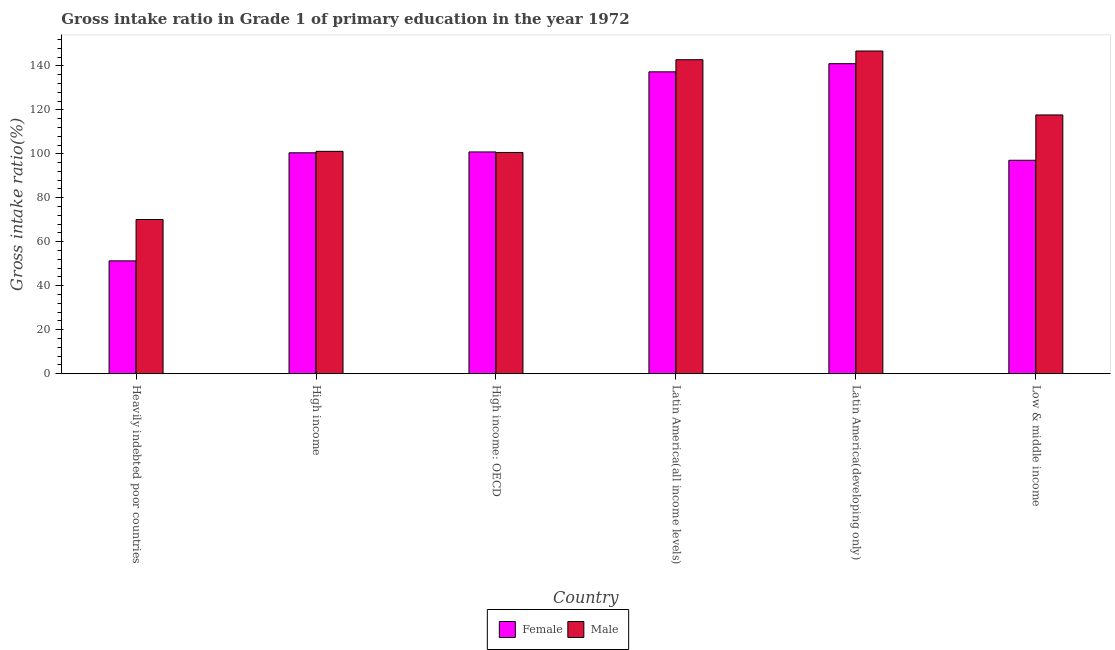How many different coloured bars are there?
Your answer should be very brief. 2. How many groups of bars are there?
Your response must be concise. 6. Are the number of bars per tick equal to the number of legend labels?
Offer a very short reply. Yes. How many bars are there on the 5th tick from the left?
Your response must be concise. 2. What is the label of the 3rd group of bars from the left?
Your answer should be very brief. High income: OECD. What is the gross intake ratio(male) in Heavily indebted poor countries?
Make the answer very short. 70.13. Across all countries, what is the maximum gross intake ratio(female)?
Provide a succinct answer. 140.97. Across all countries, what is the minimum gross intake ratio(female)?
Provide a short and direct response. 51.32. In which country was the gross intake ratio(male) maximum?
Offer a very short reply. Latin America(developing only). In which country was the gross intake ratio(female) minimum?
Offer a very short reply. Heavily indebted poor countries. What is the total gross intake ratio(male) in the graph?
Make the answer very short. 679.07. What is the difference between the gross intake ratio(male) in Latin America(all income levels) and that in Latin America(developing only)?
Offer a terse response. -3.96. What is the difference between the gross intake ratio(female) in Low & middle income and the gross intake ratio(male) in High income?
Provide a short and direct response. -4.07. What is the average gross intake ratio(male) per country?
Ensure brevity in your answer.  113.18. What is the difference between the gross intake ratio(male) and gross intake ratio(female) in Latin America(all income levels)?
Offer a terse response. 5.51. In how many countries, is the gross intake ratio(female) greater than 36 %?
Your answer should be compact. 6. What is the ratio of the gross intake ratio(male) in High income: OECD to that in Latin America(all income levels)?
Your response must be concise. 0.7. What is the difference between the highest and the second highest gross intake ratio(female)?
Provide a short and direct response. 3.7. What is the difference between the highest and the lowest gross intake ratio(male)?
Offer a very short reply. 76.61. In how many countries, is the gross intake ratio(female) greater than the average gross intake ratio(female) taken over all countries?
Keep it short and to the point. 2. What does the 2nd bar from the left in Latin America(all income levels) represents?
Give a very brief answer. Male. Are all the bars in the graph horizontal?
Your answer should be compact. No. What is the difference between two consecutive major ticks on the Y-axis?
Provide a succinct answer. 20. Are the values on the major ticks of Y-axis written in scientific E-notation?
Ensure brevity in your answer.  No. Does the graph contain any zero values?
Make the answer very short. No. Where does the legend appear in the graph?
Make the answer very short. Bottom center. How are the legend labels stacked?
Keep it short and to the point. Horizontal. What is the title of the graph?
Your answer should be very brief. Gross intake ratio in Grade 1 of primary education in the year 1972. What is the label or title of the Y-axis?
Offer a very short reply. Gross intake ratio(%). What is the Gross intake ratio(%) in Female in Heavily indebted poor countries?
Give a very brief answer. 51.32. What is the Gross intake ratio(%) in Male in Heavily indebted poor countries?
Provide a short and direct response. 70.13. What is the Gross intake ratio(%) of Female in High income?
Provide a short and direct response. 100.46. What is the Gross intake ratio(%) in Male in High income?
Your answer should be compact. 101.13. What is the Gross intake ratio(%) in Female in High income: OECD?
Offer a terse response. 100.85. What is the Gross intake ratio(%) of Male in High income: OECD?
Keep it short and to the point. 100.62. What is the Gross intake ratio(%) of Female in Latin America(all income levels)?
Ensure brevity in your answer.  137.27. What is the Gross intake ratio(%) of Male in Latin America(all income levels)?
Your response must be concise. 142.78. What is the Gross intake ratio(%) of Female in Latin America(developing only)?
Provide a succinct answer. 140.97. What is the Gross intake ratio(%) of Male in Latin America(developing only)?
Keep it short and to the point. 146.74. What is the Gross intake ratio(%) in Female in Low & middle income?
Make the answer very short. 97.06. What is the Gross intake ratio(%) of Male in Low & middle income?
Your answer should be very brief. 117.67. Across all countries, what is the maximum Gross intake ratio(%) in Female?
Provide a short and direct response. 140.97. Across all countries, what is the maximum Gross intake ratio(%) of Male?
Give a very brief answer. 146.74. Across all countries, what is the minimum Gross intake ratio(%) of Female?
Keep it short and to the point. 51.32. Across all countries, what is the minimum Gross intake ratio(%) of Male?
Provide a short and direct response. 70.13. What is the total Gross intake ratio(%) in Female in the graph?
Offer a terse response. 627.94. What is the total Gross intake ratio(%) of Male in the graph?
Provide a short and direct response. 679.07. What is the difference between the Gross intake ratio(%) of Female in Heavily indebted poor countries and that in High income?
Provide a short and direct response. -49.14. What is the difference between the Gross intake ratio(%) of Male in Heavily indebted poor countries and that in High income?
Ensure brevity in your answer.  -31. What is the difference between the Gross intake ratio(%) in Female in Heavily indebted poor countries and that in High income: OECD?
Make the answer very short. -49.52. What is the difference between the Gross intake ratio(%) in Male in Heavily indebted poor countries and that in High income: OECD?
Give a very brief answer. -30.49. What is the difference between the Gross intake ratio(%) of Female in Heavily indebted poor countries and that in Latin America(all income levels)?
Provide a succinct answer. -85.95. What is the difference between the Gross intake ratio(%) in Male in Heavily indebted poor countries and that in Latin America(all income levels)?
Provide a succinct answer. -72.65. What is the difference between the Gross intake ratio(%) in Female in Heavily indebted poor countries and that in Latin America(developing only)?
Make the answer very short. -89.65. What is the difference between the Gross intake ratio(%) of Male in Heavily indebted poor countries and that in Latin America(developing only)?
Keep it short and to the point. -76.61. What is the difference between the Gross intake ratio(%) in Female in Heavily indebted poor countries and that in Low & middle income?
Your answer should be compact. -45.74. What is the difference between the Gross intake ratio(%) in Male in Heavily indebted poor countries and that in Low & middle income?
Make the answer very short. -47.54. What is the difference between the Gross intake ratio(%) in Female in High income and that in High income: OECD?
Your answer should be compact. -0.39. What is the difference between the Gross intake ratio(%) in Male in High income and that in High income: OECD?
Keep it short and to the point. 0.51. What is the difference between the Gross intake ratio(%) in Female in High income and that in Latin America(all income levels)?
Give a very brief answer. -36.81. What is the difference between the Gross intake ratio(%) in Male in High income and that in Latin America(all income levels)?
Your answer should be very brief. -41.66. What is the difference between the Gross intake ratio(%) of Female in High income and that in Latin America(developing only)?
Make the answer very short. -40.51. What is the difference between the Gross intake ratio(%) of Male in High income and that in Latin America(developing only)?
Your response must be concise. -45.61. What is the difference between the Gross intake ratio(%) of Female in High income and that in Low & middle income?
Offer a terse response. 3.4. What is the difference between the Gross intake ratio(%) of Male in High income and that in Low & middle income?
Your response must be concise. -16.54. What is the difference between the Gross intake ratio(%) in Female in High income: OECD and that in Latin America(all income levels)?
Keep it short and to the point. -36.42. What is the difference between the Gross intake ratio(%) in Male in High income: OECD and that in Latin America(all income levels)?
Provide a succinct answer. -42.17. What is the difference between the Gross intake ratio(%) of Female in High income: OECD and that in Latin America(developing only)?
Offer a terse response. -40.13. What is the difference between the Gross intake ratio(%) in Male in High income: OECD and that in Latin America(developing only)?
Your response must be concise. -46.13. What is the difference between the Gross intake ratio(%) in Female in High income: OECD and that in Low & middle income?
Give a very brief answer. 3.79. What is the difference between the Gross intake ratio(%) of Male in High income: OECD and that in Low & middle income?
Your answer should be very brief. -17.05. What is the difference between the Gross intake ratio(%) in Female in Latin America(all income levels) and that in Latin America(developing only)?
Give a very brief answer. -3.7. What is the difference between the Gross intake ratio(%) of Male in Latin America(all income levels) and that in Latin America(developing only)?
Make the answer very short. -3.96. What is the difference between the Gross intake ratio(%) of Female in Latin America(all income levels) and that in Low & middle income?
Provide a short and direct response. 40.21. What is the difference between the Gross intake ratio(%) in Male in Latin America(all income levels) and that in Low & middle income?
Offer a very short reply. 25.11. What is the difference between the Gross intake ratio(%) of Female in Latin America(developing only) and that in Low & middle income?
Give a very brief answer. 43.91. What is the difference between the Gross intake ratio(%) of Male in Latin America(developing only) and that in Low & middle income?
Make the answer very short. 29.07. What is the difference between the Gross intake ratio(%) in Female in Heavily indebted poor countries and the Gross intake ratio(%) in Male in High income?
Keep it short and to the point. -49.81. What is the difference between the Gross intake ratio(%) of Female in Heavily indebted poor countries and the Gross intake ratio(%) of Male in High income: OECD?
Provide a succinct answer. -49.29. What is the difference between the Gross intake ratio(%) of Female in Heavily indebted poor countries and the Gross intake ratio(%) of Male in Latin America(all income levels)?
Provide a short and direct response. -91.46. What is the difference between the Gross intake ratio(%) in Female in Heavily indebted poor countries and the Gross intake ratio(%) in Male in Latin America(developing only)?
Offer a very short reply. -95.42. What is the difference between the Gross intake ratio(%) in Female in Heavily indebted poor countries and the Gross intake ratio(%) in Male in Low & middle income?
Give a very brief answer. -66.35. What is the difference between the Gross intake ratio(%) in Female in High income and the Gross intake ratio(%) in Male in High income: OECD?
Ensure brevity in your answer.  -0.16. What is the difference between the Gross intake ratio(%) of Female in High income and the Gross intake ratio(%) of Male in Latin America(all income levels)?
Offer a terse response. -42.32. What is the difference between the Gross intake ratio(%) of Female in High income and the Gross intake ratio(%) of Male in Latin America(developing only)?
Ensure brevity in your answer.  -46.28. What is the difference between the Gross intake ratio(%) of Female in High income and the Gross intake ratio(%) of Male in Low & middle income?
Your answer should be compact. -17.21. What is the difference between the Gross intake ratio(%) in Female in High income: OECD and the Gross intake ratio(%) in Male in Latin America(all income levels)?
Ensure brevity in your answer.  -41.94. What is the difference between the Gross intake ratio(%) in Female in High income: OECD and the Gross intake ratio(%) in Male in Latin America(developing only)?
Your response must be concise. -45.89. What is the difference between the Gross intake ratio(%) in Female in High income: OECD and the Gross intake ratio(%) in Male in Low & middle income?
Ensure brevity in your answer.  -16.82. What is the difference between the Gross intake ratio(%) of Female in Latin America(all income levels) and the Gross intake ratio(%) of Male in Latin America(developing only)?
Your response must be concise. -9.47. What is the difference between the Gross intake ratio(%) of Female in Latin America(all income levels) and the Gross intake ratio(%) of Male in Low & middle income?
Make the answer very short. 19.6. What is the difference between the Gross intake ratio(%) in Female in Latin America(developing only) and the Gross intake ratio(%) in Male in Low & middle income?
Provide a short and direct response. 23.3. What is the average Gross intake ratio(%) of Female per country?
Provide a short and direct response. 104.66. What is the average Gross intake ratio(%) in Male per country?
Provide a succinct answer. 113.18. What is the difference between the Gross intake ratio(%) in Female and Gross intake ratio(%) in Male in Heavily indebted poor countries?
Offer a very short reply. -18.81. What is the difference between the Gross intake ratio(%) of Female and Gross intake ratio(%) of Male in High income?
Provide a short and direct response. -0.67. What is the difference between the Gross intake ratio(%) in Female and Gross intake ratio(%) in Male in High income: OECD?
Keep it short and to the point. 0.23. What is the difference between the Gross intake ratio(%) in Female and Gross intake ratio(%) in Male in Latin America(all income levels)?
Your response must be concise. -5.51. What is the difference between the Gross intake ratio(%) of Female and Gross intake ratio(%) of Male in Latin America(developing only)?
Your response must be concise. -5.77. What is the difference between the Gross intake ratio(%) in Female and Gross intake ratio(%) in Male in Low & middle income?
Provide a short and direct response. -20.61. What is the ratio of the Gross intake ratio(%) in Female in Heavily indebted poor countries to that in High income?
Give a very brief answer. 0.51. What is the ratio of the Gross intake ratio(%) in Male in Heavily indebted poor countries to that in High income?
Offer a terse response. 0.69. What is the ratio of the Gross intake ratio(%) in Female in Heavily indebted poor countries to that in High income: OECD?
Your response must be concise. 0.51. What is the ratio of the Gross intake ratio(%) in Male in Heavily indebted poor countries to that in High income: OECD?
Make the answer very short. 0.7. What is the ratio of the Gross intake ratio(%) in Female in Heavily indebted poor countries to that in Latin America(all income levels)?
Give a very brief answer. 0.37. What is the ratio of the Gross intake ratio(%) of Male in Heavily indebted poor countries to that in Latin America(all income levels)?
Give a very brief answer. 0.49. What is the ratio of the Gross intake ratio(%) of Female in Heavily indebted poor countries to that in Latin America(developing only)?
Provide a short and direct response. 0.36. What is the ratio of the Gross intake ratio(%) in Male in Heavily indebted poor countries to that in Latin America(developing only)?
Make the answer very short. 0.48. What is the ratio of the Gross intake ratio(%) of Female in Heavily indebted poor countries to that in Low & middle income?
Your answer should be compact. 0.53. What is the ratio of the Gross intake ratio(%) in Male in Heavily indebted poor countries to that in Low & middle income?
Provide a succinct answer. 0.6. What is the ratio of the Gross intake ratio(%) of Female in High income to that in High income: OECD?
Provide a short and direct response. 1. What is the ratio of the Gross intake ratio(%) in Male in High income to that in High income: OECD?
Provide a succinct answer. 1.01. What is the ratio of the Gross intake ratio(%) in Female in High income to that in Latin America(all income levels)?
Keep it short and to the point. 0.73. What is the ratio of the Gross intake ratio(%) of Male in High income to that in Latin America(all income levels)?
Give a very brief answer. 0.71. What is the ratio of the Gross intake ratio(%) of Female in High income to that in Latin America(developing only)?
Keep it short and to the point. 0.71. What is the ratio of the Gross intake ratio(%) in Male in High income to that in Latin America(developing only)?
Your answer should be very brief. 0.69. What is the ratio of the Gross intake ratio(%) of Female in High income to that in Low & middle income?
Your response must be concise. 1.03. What is the ratio of the Gross intake ratio(%) in Male in High income to that in Low & middle income?
Your answer should be very brief. 0.86. What is the ratio of the Gross intake ratio(%) in Female in High income: OECD to that in Latin America(all income levels)?
Keep it short and to the point. 0.73. What is the ratio of the Gross intake ratio(%) in Male in High income: OECD to that in Latin America(all income levels)?
Your response must be concise. 0.7. What is the ratio of the Gross intake ratio(%) in Female in High income: OECD to that in Latin America(developing only)?
Make the answer very short. 0.72. What is the ratio of the Gross intake ratio(%) in Male in High income: OECD to that in Latin America(developing only)?
Your answer should be compact. 0.69. What is the ratio of the Gross intake ratio(%) in Female in High income: OECD to that in Low & middle income?
Make the answer very short. 1.04. What is the ratio of the Gross intake ratio(%) of Male in High income: OECD to that in Low & middle income?
Keep it short and to the point. 0.86. What is the ratio of the Gross intake ratio(%) of Female in Latin America(all income levels) to that in Latin America(developing only)?
Your answer should be compact. 0.97. What is the ratio of the Gross intake ratio(%) in Male in Latin America(all income levels) to that in Latin America(developing only)?
Make the answer very short. 0.97. What is the ratio of the Gross intake ratio(%) in Female in Latin America(all income levels) to that in Low & middle income?
Provide a short and direct response. 1.41. What is the ratio of the Gross intake ratio(%) in Male in Latin America(all income levels) to that in Low & middle income?
Provide a short and direct response. 1.21. What is the ratio of the Gross intake ratio(%) of Female in Latin America(developing only) to that in Low & middle income?
Make the answer very short. 1.45. What is the ratio of the Gross intake ratio(%) of Male in Latin America(developing only) to that in Low & middle income?
Your answer should be very brief. 1.25. What is the difference between the highest and the second highest Gross intake ratio(%) of Female?
Give a very brief answer. 3.7. What is the difference between the highest and the second highest Gross intake ratio(%) of Male?
Provide a short and direct response. 3.96. What is the difference between the highest and the lowest Gross intake ratio(%) in Female?
Your answer should be compact. 89.65. What is the difference between the highest and the lowest Gross intake ratio(%) in Male?
Provide a succinct answer. 76.61. 